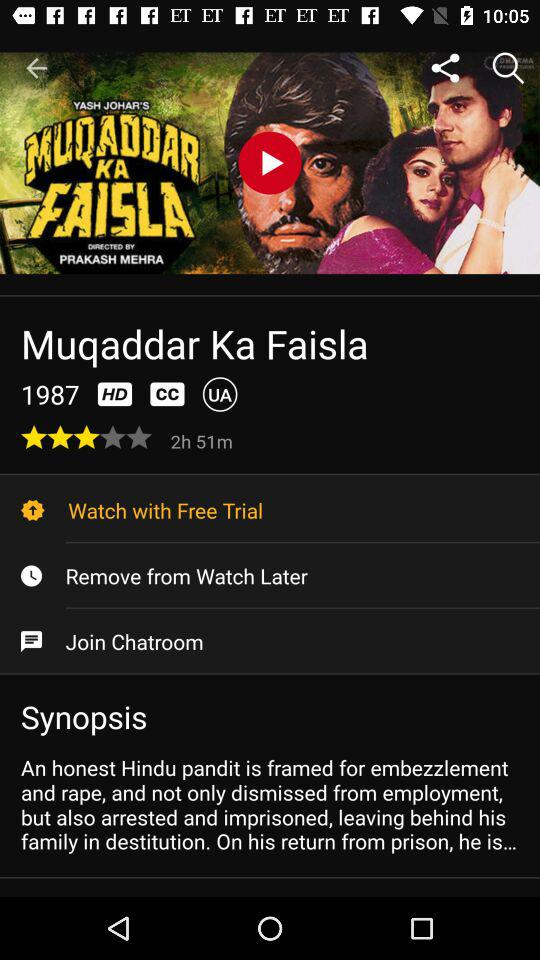What is the rating of the movie? The rating of the movie is 3 stars. 